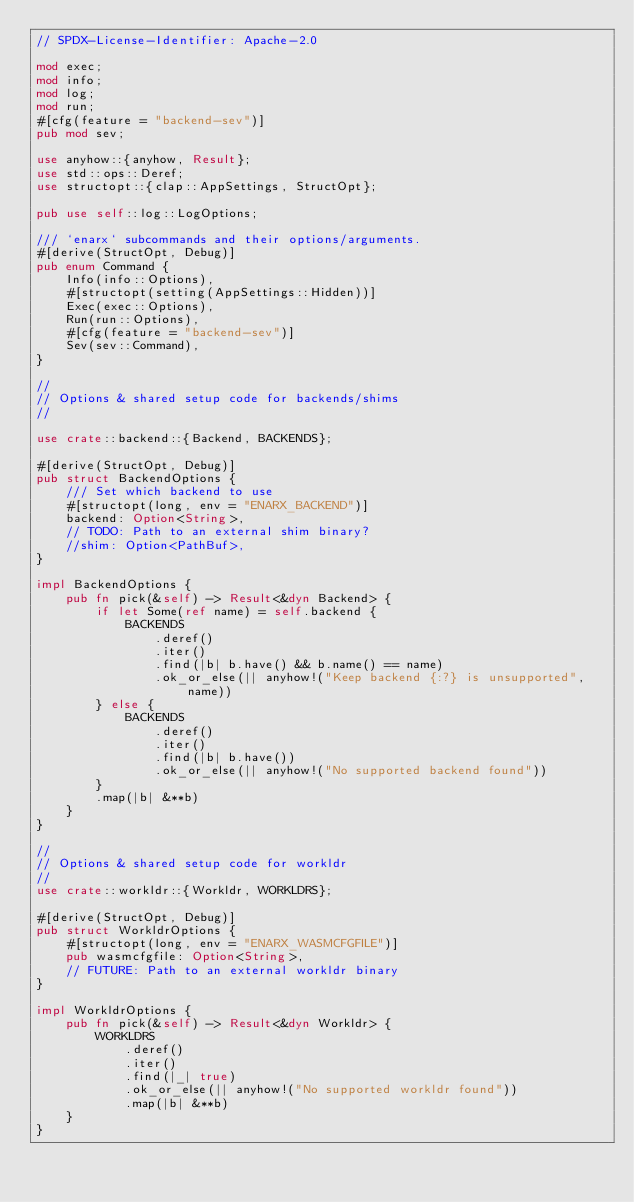<code> <loc_0><loc_0><loc_500><loc_500><_Rust_>// SPDX-License-Identifier: Apache-2.0

mod exec;
mod info;
mod log;
mod run;
#[cfg(feature = "backend-sev")]
pub mod sev;

use anyhow::{anyhow, Result};
use std::ops::Deref;
use structopt::{clap::AppSettings, StructOpt};

pub use self::log::LogOptions;

/// `enarx` subcommands and their options/arguments.
#[derive(StructOpt, Debug)]
pub enum Command {
    Info(info::Options),
    #[structopt(setting(AppSettings::Hidden))]
    Exec(exec::Options),
    Run(run::Options),
    #[cfg(feature = "backend-sev")]
    Sev(sev::Command),
}

//
// Options & shared setup code for backends/shims
//

use crate::backend::{Backend, BACKENDS};

#[derive(StructOpt, Debug)]
pub struct BackendOptions {
    /// Set which backend to use
    #[structopt(long, env = "ENARX_BACKEND")]
    backend: Option<String>,
    // TODO: Path to an external shim binary?
    //shim: Option<PathBuf>,
}

impl BackendOptions {
    pub fn pick(&self) -> Result<&dyn Backend> {
        if let Some(ref name) = self.backend {
            BACKENDS
                .deref()
                .iter()
                .find(|b| b.have() && b.name() == name)
                .ok_or_else(|| anyhow!("Keep backend {:?} is unsupported", name))
        } else {
            BACKENDS
                .deref()
                .iter()
                .find(|b| b.have())
                .ok_or_else(|| anyhow!("No supported backend found"))
        }
        .map(|b| &**b)
    }
}

//
// Options & shared setup code for workldr
//
use crate::workldr::{Workldr, WORKLDRS};

#[derive(StructOpt, Debug)]
pub struct WorkldrOptions {
    #[structopt(long, env = "ENARX_WASMCFGFILE")]
    pub wasmcfgfile: Option<String>,
    // FUTURE: Path to an external workldr binary
}

impl WorkldrOptions {
    pub fn pick(&self) -> Result<&dyn Workldr> {
        WORKLDRS
            .deref()
            .iter()
            .find(|_| true)
            .ok_or_else(|| anyhow!("No supported workldr found"))
            .map(|b| &**b)
    }
}
</code> 